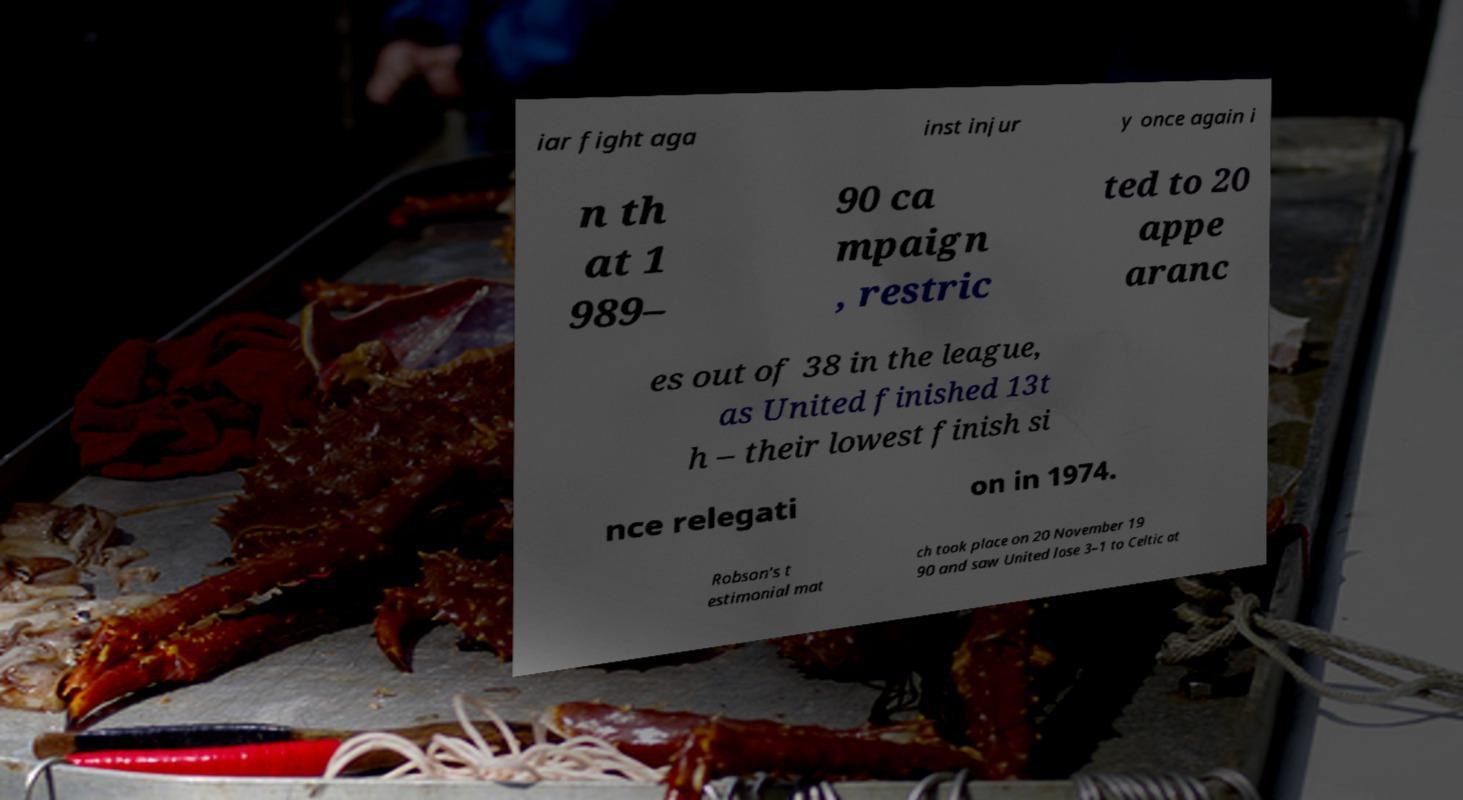Can you accurately transcribe the text from the provided image for me? iar fight aga inst injur y once again i n th at 1 989– 90 ca mpaign , restric ted to 20 appe aranc es out of 38 in the league, as United finished 13t h – their lowest finish si nce relegati on in 1974. Robson's t estimonial mat ch took place on 20 November 19 90 and saw United lose 3–1 to Celtic at 